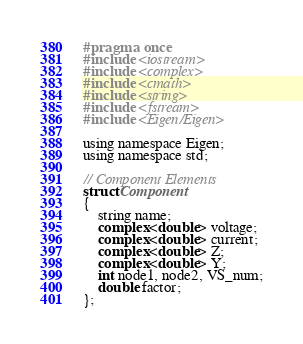Convert code to text. <code><loc_0><loc_0><loc_500><loc_500><_C_>#pragma once
#include <iostream>
#include <complex>
#include <cmath>
#include <string>
#include <fstream>
#include <Eigen/Eigen>

using namespace Eigen;
using namespace std;

// Component Elements
struct Component
{
	string name;
	complex<double> voltage;
	complex<double> current;
	complex<double> Z;
	complex<double> Y;
	int node1, node2, VS_num;
	double factor;
};
</code> 